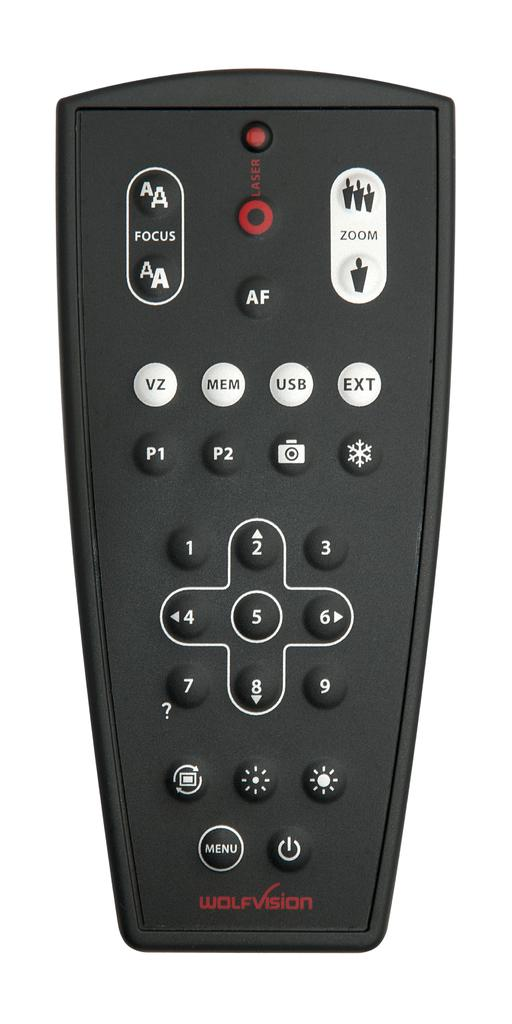<image>
Provide a brief description of the given image. A Wolfvision brand remote control with many buttons such as those that control focus and zoom. 